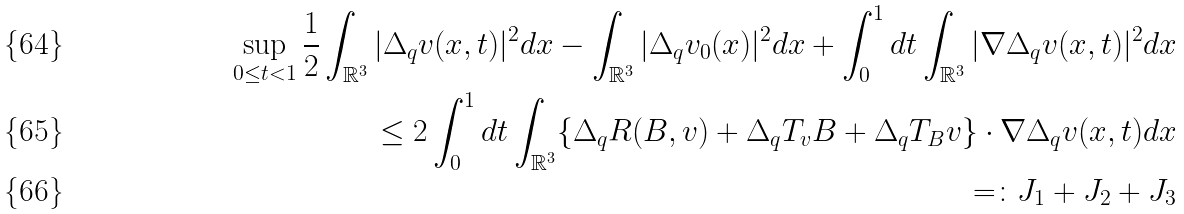<formula> <loc_0><loc_0><loc_500><loc_500>\sup _ { 0 \leq t < 1 } \frac { 1 } { 2 } \int _ { \mathbb { R } ^ { 3 } } | \Delta _ { q } v ( x , t ) | ^ { 2 } d x - \int _ { \mathbb { R } ^ { 3 } } | \Delta _ { q } v _ { 0 } ( x ) | ^ { 2 } d x + \int _ { 0 } ^ { 1 } d t \int _ { \mathbb { R } ^ { 3 } } | \nabla \Delta _ { q } v ( x , t ) | ^ { 2 } d x \\ \leq 2 \int _ { 0 } ^ { 1 } d t \int _ { \mathbb { R } ^ { 3 } } \{ \Delta _ { q } R ( B , v ) + \Delta _ { q } T _ { v } B + \Delta _ { q } T _ { B } v \} \cdot \nabla \Delta _ { q } v ( x , t ) d x \\ = \colon J _ { 1 } + J _ { 2 } + J _ { 3 }</formula> 